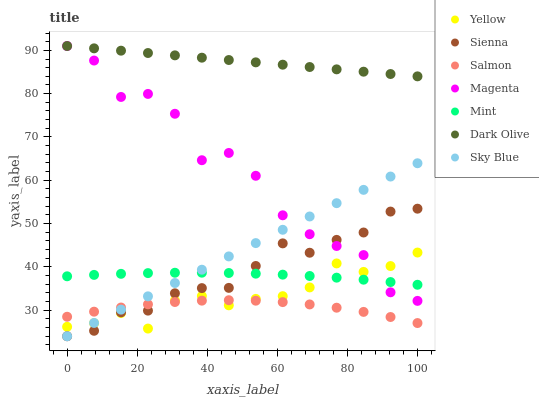Does Salmon have the minimum area under the curve?
Answer yes or no. Yes. Does Dark Olive have the maximum area under the curve?
Answer yes or no. Yes. Does Yellow have the minimum area under the curve?
Answer yes or no. No. Does Yellow have the maximum area under the curve?
Answer yes or no. No. Is Dark Olive the smoothest?
Answer yes or no. Yes. Is Magenta the roughest?
Answer yes or no. Yes. Is Salmon the smoothest?
Answer yes or no. No. Is Salmon the roughest?
Answer yes or no. No. Does Sienna have the lowest value?
Answer yes or no. Yes. Does Salmon have the lowest value?
Answer yes or no. No. Does Magenta have the highest value?
Answer yes or no. Yes. Does Yellow have the highest value?
Answer yes or no. No. Is Sienna less than Dark Olive?
Answer yes or no. Yes. Is Mint greater than Salmon?
Answer yes or no. Yes. Does Magenta intersect Mint?
Answer yes or no. Yes. Is Magenta less than Mint?
Answer yes or no. No. Is Magenta greater than Mint?
Answer yes or no. No. Does Sienna intersect Dark Olive?
Answer yes or no. No. 